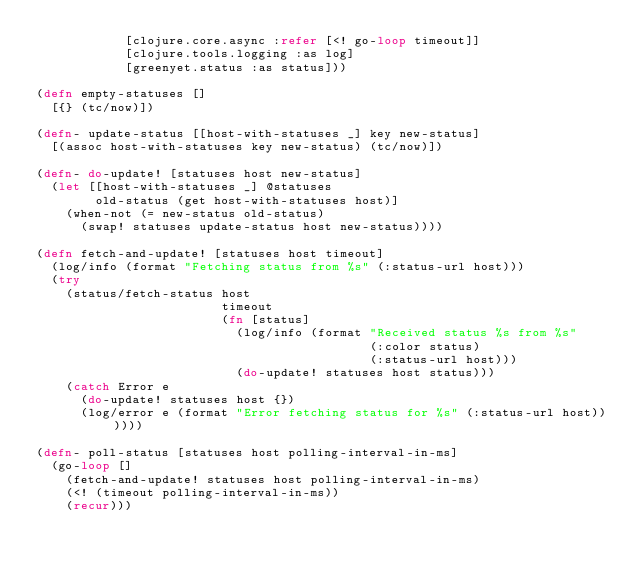Convert code to text. <code><loc_0><loc_0><loc_500><loc_500><_Clojure_>            [clojure.core.async :refer [<! go-loop timeout]]
            [clojure.tools.logging :as log]
            [greenyet.status :as status]))

(defn empty-statuses []
  [{} (tc/now)])

(defn- update-status [[host-with-statuses _] key new-status]
  [(assoc host-with-statuses key new-status) (tc/now)])

(defn- do-update! [statuses host new-status]
  (let [[host-with-statuses _] @statuses
        old-status (get host-with-statuses host)]
    (when-not (= new-status old-status)
      (swap! statuses update-status host new-status))))

(defn fetch-and-update! [statuses host timeout]
  (log/info (format "Fetching status from %s" (:status-url host)))
  (try
    (status/fetch-status host
                         timeout
                         (fn [status]
                           (log/info (format "Received status %s from %s"
                                             (:color status)
                                             (:status-url host)))
                           (do-update! statuses host status)))
    (catch Error e
      (do-update! statuses host {})
      (log/error e (format "Error fetching status for %s" (:status-url host))))))

(defn- poll-status [statuses host polling-interval-in-ms]
  (go-loop []
    (fetch-and-update! statuses host polling-interval-in-ms)
    (<! (timeout polling-interval-in-ms))
    (recur)))

</code> 